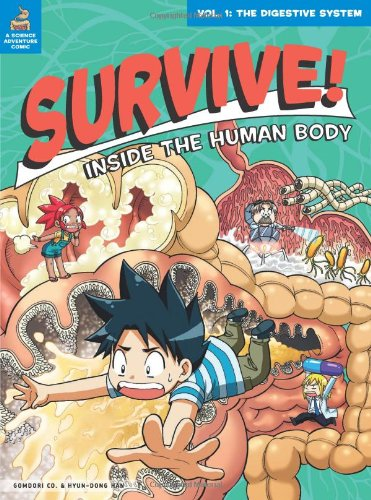Who is the author of this book?
Answer the question using a single word or phrase. Gomdori co. What is the title of this book? Survive! Inside the Human Body, Vol. 1: The Digestive System What is the genre of this book? Children's Books Is this book related to Children's Books? Yes Is this book related to Arts & Photography? No 